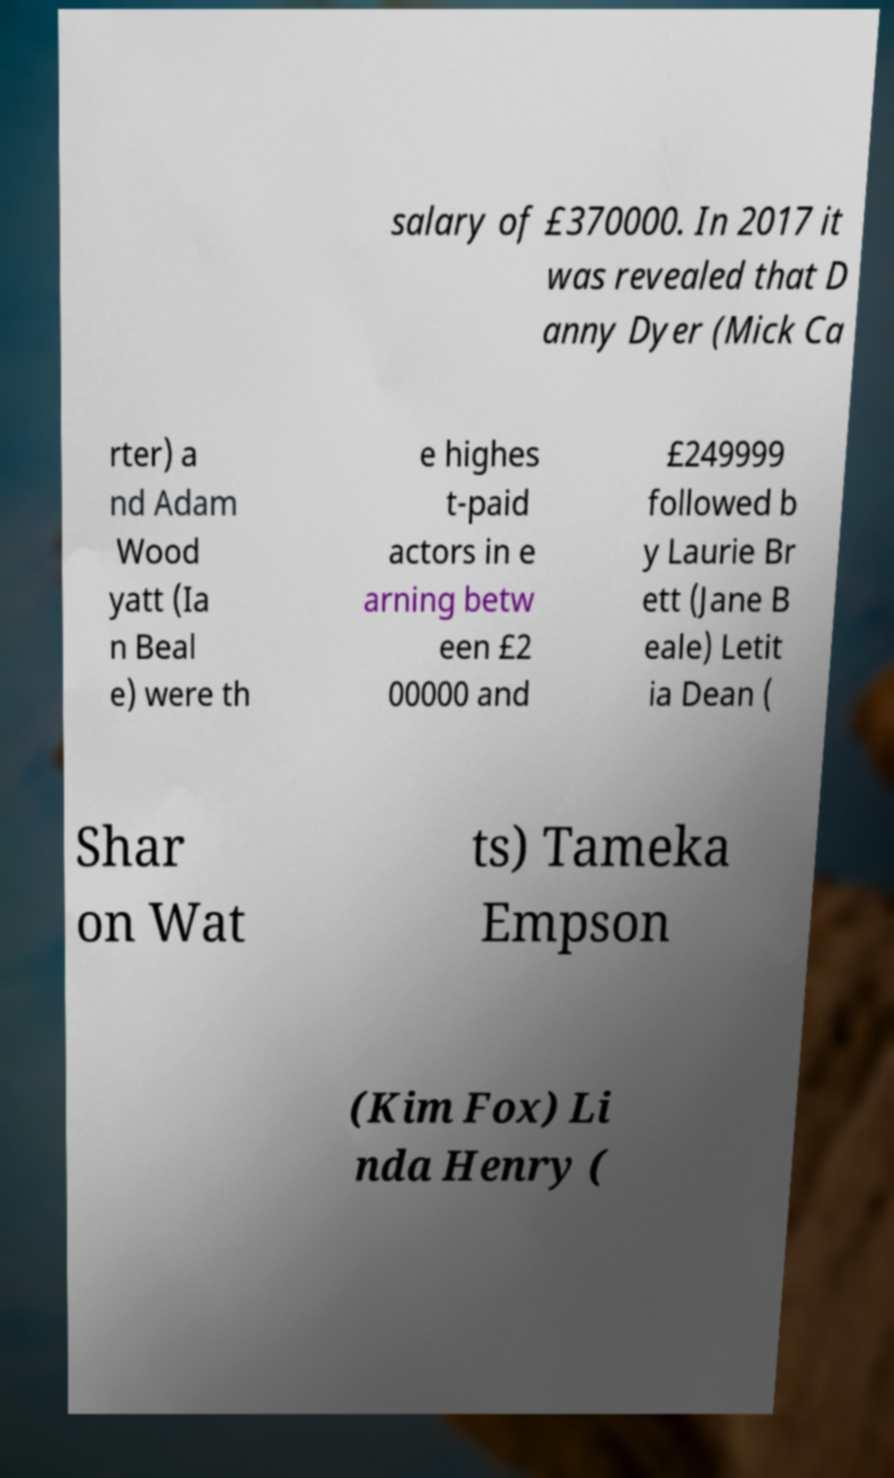There's text embedded in this image that I need extracted. Can you transcribe it verbatim? salary of £370000. In 2017 it was revealed that D anny Dyer (Mick Ca rter) a nd Adam Wood yatt (Ia n Beal e) were th e highes t-paid actors in e arning betw een £2 00000 and £249999 followed b y Laurie Br ett (Jane B eale) Letit ia Dean ( Shar on Wat ts) Tameka Empson (Kim Fox) Li nda Henry ( 